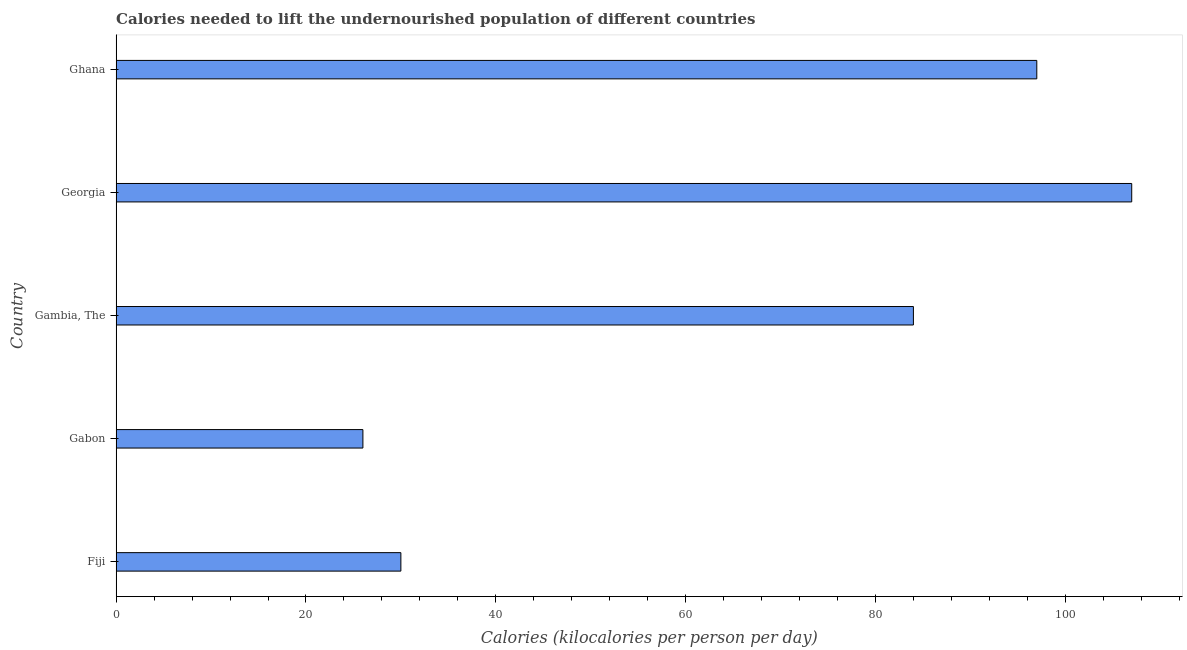What is the title of the graph?
Offer a terse response. Calories needed to lift the undernourished population of different countries. What is the label or title of the X-axis?
Your answer should be very brief. Calories (kilocalories per person per day). What is the label or title of the Y-axis?
Your answer should be very brief. Country. What is the depth of food deficit in Georgia?
Your answer should be very brief. 107. Across all countries, what is the maximum depth of food deficit?
Your answer should be compact. 107. In which country was the depth of food deficit maximum?
Provide a succinct answer. Georgia. In which country was the depth of food deficit minimum?
Provide a short and direct response. Gabon. What is the sum of the depth of food deficit?
Make the answer very short. 344. What is the difference between the depth of food deficit in Gambia, The and Georgia?
Offer a terse response. -23. What is the average depth of food deficit per country?
Make the answer very short. 68.8. What is the median depth of food deficit?
Your answer should be very brief. 84. What is the ratio of the depth of food deficit in Gambia, The to that in Ghana?
Offer a terse response. 0.87. Is the sum of the depth of food deficit in Fiji and Ghana greater than the maximum depth of food deficit across all countries?
Your response must be concise. Yes. In how many countries, is the depth of food deficit greater than the average depth of food deficit taken over all countries?
Your response must be concise. 3. Are all the bars in the graph horizontal?
Offer a very short reply. Yes. What is the Calories (kilocalories per person per day) in Fiji?
Give a very brief answer. 30. What is the Calories (kilocalories per person per day) of Gabon?
Offer a very short reply. 26. What is the Calories (kilocalories per person per day) in Gambia, The?
Ensure brevity in your answer.  84. What is the Calories (kilocalories per person per day) in Georgia?
Provide a succinct answer. 107. What is the Calories (kilocalories per person per day) in Ghana?
Provide a short and direct response. 97. What is the difference between the Calories (kilocalories per person per day) in Fiji and Gabon?
Give a very brief answer. 4. What is the difference between the Calories (kilocalories per person per day) in Fiji and Gambia, The?
Your response must be concise. -54. What is the difference between the Calories (kilocalories per person per day) in Fiji and Georgia?
Your answer should be very brief. -77. What is the difference between the Calories (kilocalories per person per day) in Fiji and Ghana?
Make the answer very short. -67. What is the difference between the Calories (kilocalories per person per day) in Gabon and Gambia, The?
Provide a succinct answer. -58. What is the difference between the Calories (kilocalories per person per day) in Gabon and Georgia?
Give a very brief answer. -81. What is the difference between the Calories (kilocalories per person per day) in Gabon and Ghana?
Provide a short and direct response. -71. What is the difference between the Calories (kilocalories per person per day) in Gambia, The and Georgia?
Give a very brief answer. -23. What is the difference between the Calories (kilocalories per person per day) in Gambia, The and Ghana?
Your response must be concise. -13. What is the difference between the Calories (kilocalories per person per day) in Georgia and Ghana?
Ensure brevity in your answer.  10. What is the ratio of the Calories (kilocalories per person per day) in Fiji to that in Gabon?
Offer a very short reply. 1.15. What is the ratio of the Calories (kilocalories per person per day) in Fiji to that in Gambia, The?
Your answer should be compact. 0.36. What is the ratio of the Calories (kilocalories per person per day) in Fiji to that in Georgia?
Make the answer very short. 0.28. What is the ratio of the Calories (kilocalories per person per day) in Fiji to that in Ghana?
Your response must be concise. 0.31. What is the ratio of the Calories (kilocalories per person per day) in Gabon to that in Gambia, The?
Offer a very short reply. 0.31. What is the ratio of the Calories (kilocalories per person per day) in Gabon to that in Georgia?
Your answer should be very brief. 0.24. What is the ratio of the Calories (kilocalories per person per day) in Gabon to that in Ghana?
Ensure brevity in your answer.  0.27. What is the ratio of the Calories (kilocalories per person per day) in Gambia, The to that in Georgia?
Make the answer very short. 0.79. What is the ratio of the Calories (kilocalories per person per day) in Gambia, The to that in Ghana?
Offer a terse response. 0.87. What is the ratio of the Calories (kilocalories per person per day) in Georgia to that in Ghana?
Your answer should be compact. 1.1. 